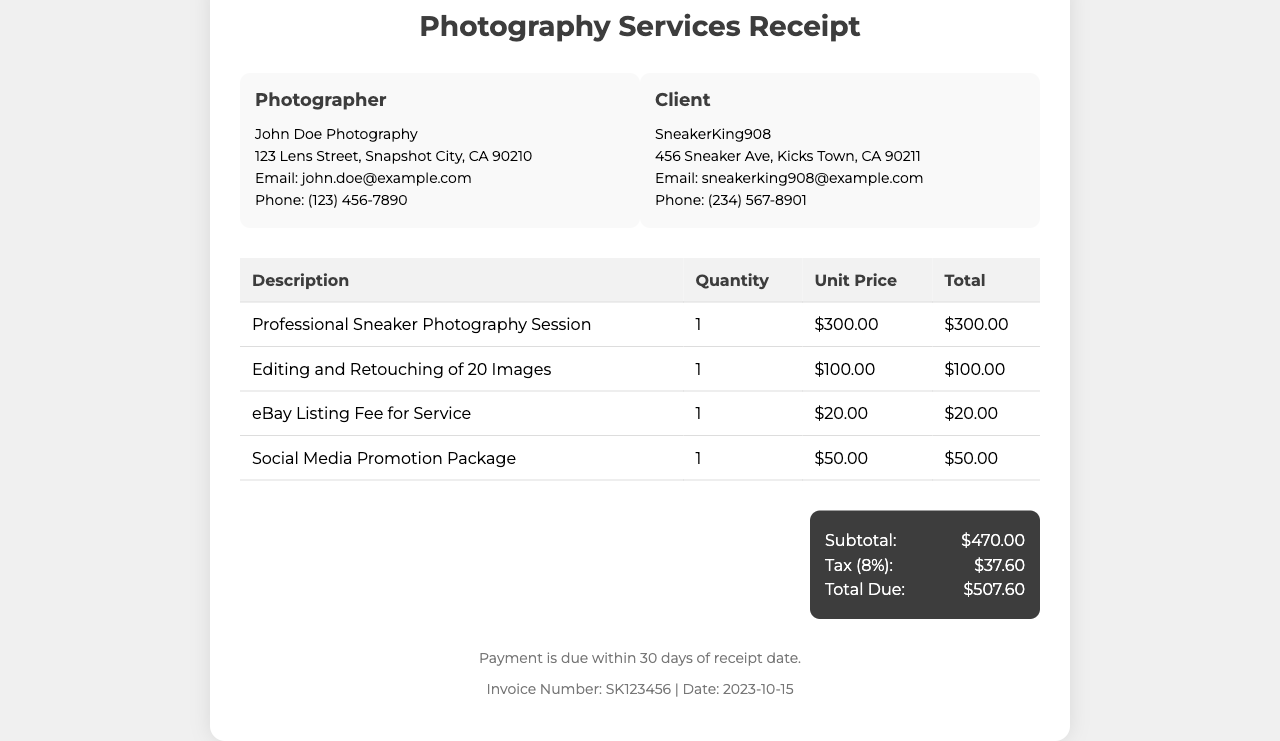What is the name of the photographer? The receipt lists the photographer's name as "John Doe Photography."
Answer: John Doe Photography What is the email address of the client? The document provides the client's email as "sneakerking908@example.com."
Answer: sneakerking908@example.com What is the unit price for the Social Media Promotion Package? The document states the unit price for the Social Media Promotion Package as $50.00.
Answer: $50.00 What is the subtotal amount on the receipt? The subtotal is the sum of all itemized charges before tax, which is $470.00.
Answer: $470.00 What percentage is applied for tax in this receipt? The tax rate mentioned in the document is 8%.
Answer: 8% What is the total due for the services rendered? The total due at the end of the receipt is $507.60.
Answer: $507.60 How many images are included for editing and retouching? The receipt indicates there are 20 images that will be edited and retouched.
Answer: 20 What is the invoice number? The document specifies the invoice number as "SK123456."
Answer: SK123456 What is the payment due date according to the terms? The terms state that payment is due within 30 days of the receipt date.
Answer: 30 days 